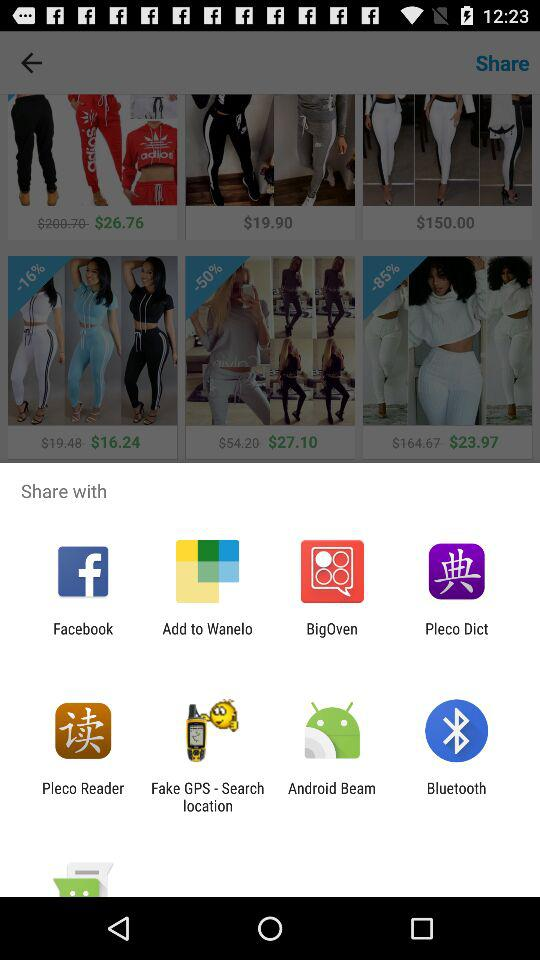Through what application can we share it? We can share it with "Facebook", "Add to Wanelo", "BigOven", "Pleco Dict", "Pleco Reader", "Fake GPS - Search location", "Android Beam" and "Bluetooth". 